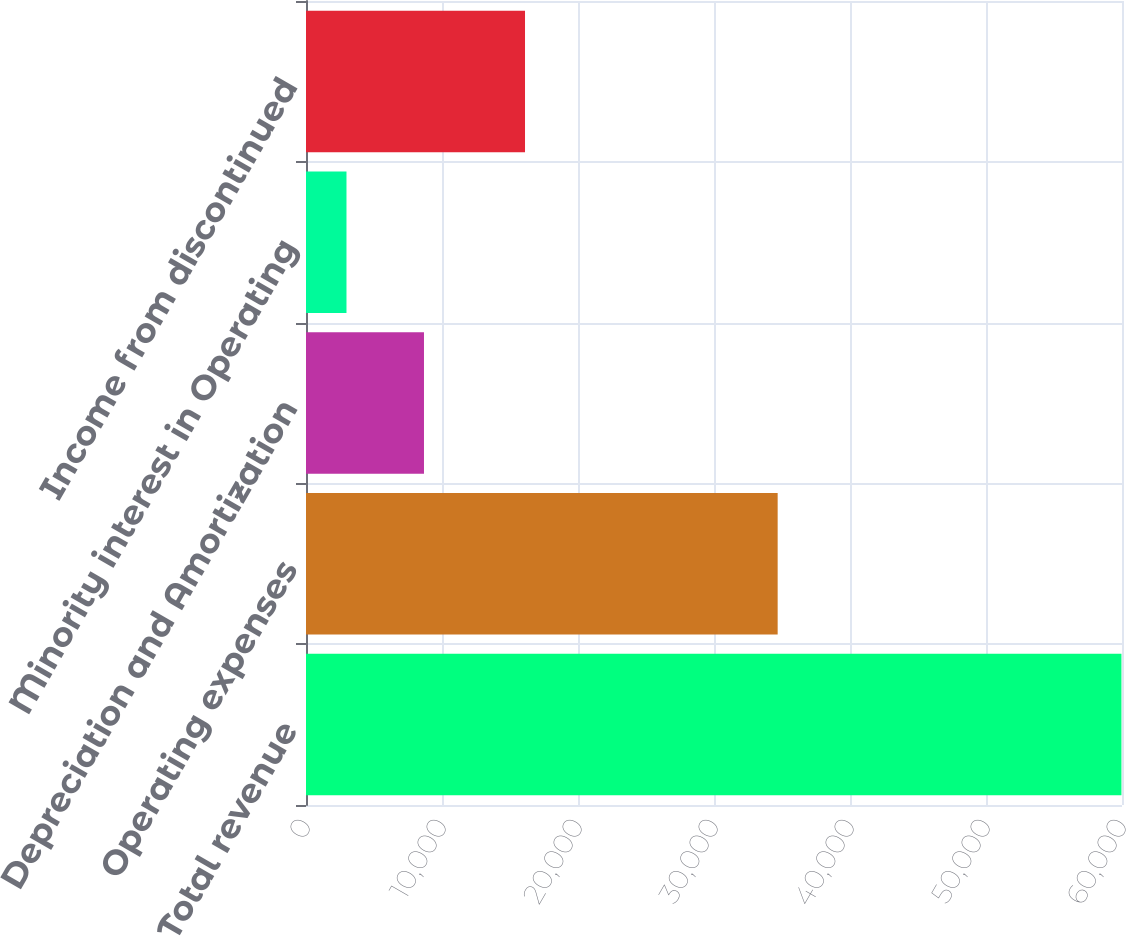Convert chart to OTSL. <chart><loc_0><loc_0><loc_500><loc_500><bar_chart><fcel>Total revenue<fcel>Operating expenses<fcel>Depreciation and Amortization<fcel>Minority interest in Operating<fcel>Income from discontinued<nl><fcel>59959<fcel>34681<fcel>8675.2<fcel>2977<fcel>16104<nl></chart> 